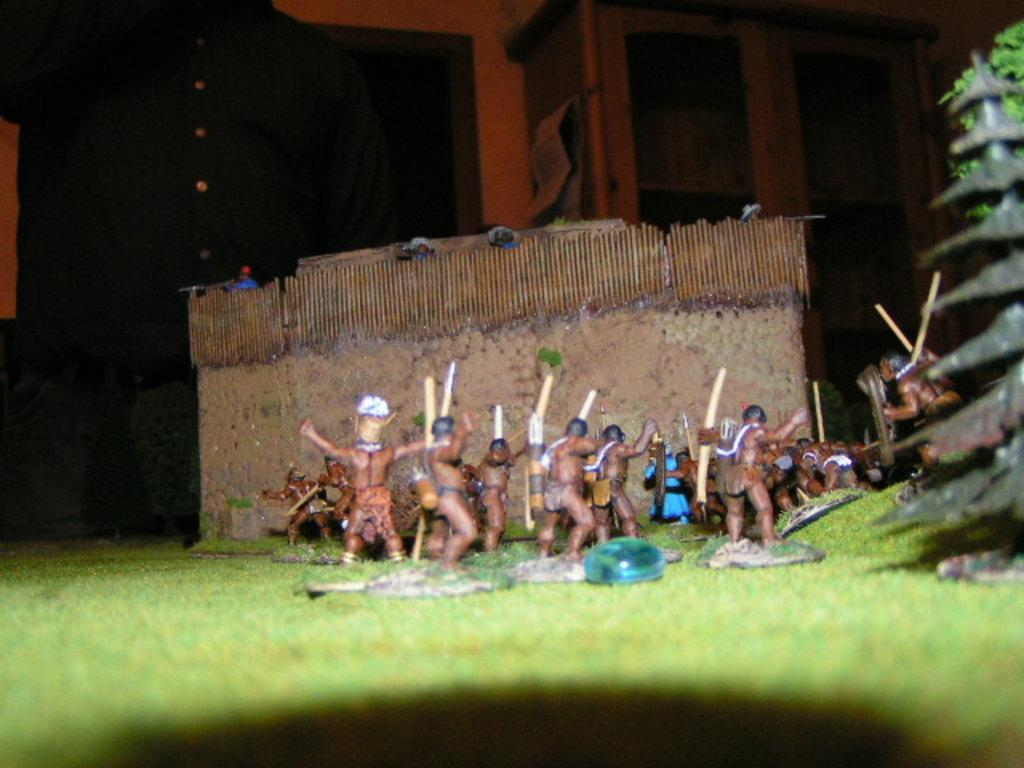What is located in the center of the image? There are toys in the center of the image. What type of flooring is visible in the image? There is carpet grass in the image. What can be seen in the background of the image? There are persons and a cupboard in the background of the image. What type of bomb can be seen in the image? There is no bomb present in the image. What material is the yard made of in the image? There is no yard present in the image; it features carpet grass instead. 